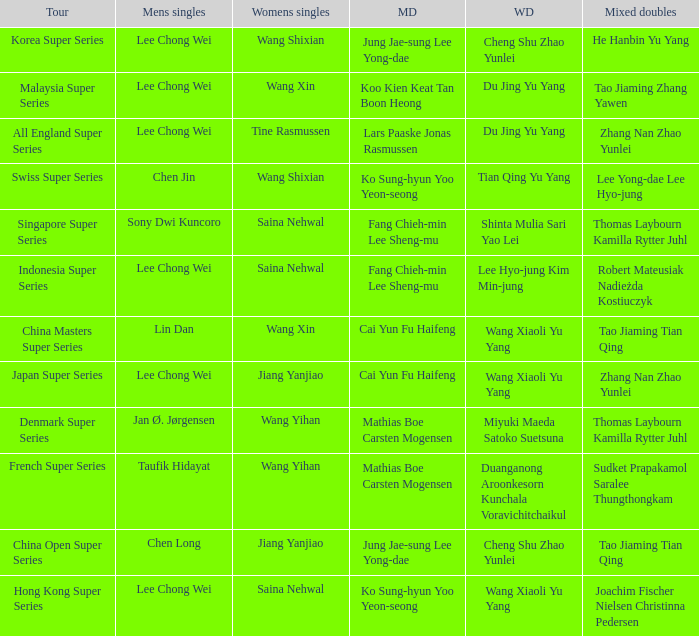Who were the womens doubles when the mixed doubles were zhang nan zhao yunlei on the tour all england super series? Du Jing Yu Yang. 